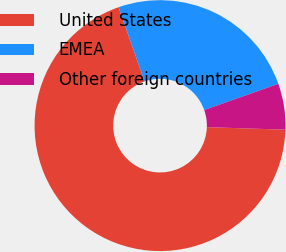Convert chart. <chart><loc_0><loc_0><loc_500><loc_500><pie_chart><fcel>United States<fcel>EMEA<fcel>Other foreign countries<nl><fcel>69.13%<fcel>24.96%<fcel>5.92%<nl></chart> 